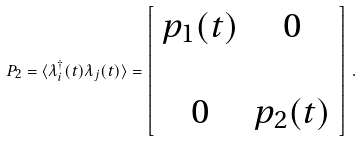Convert formula to latex. <formula><loc_0><loc_0><loc_500><loc_500>P _ { 2 } = \langle \lambda ^ { \dag } _ { i } ( t ) \lambda _ { j } ( t ) \rangle = \left [ \begin{array} { c c } p _ { 1 } ( t ) & 0 \\ & \\ 0 & p _ { 2 } ( t ) \end{array} \right ] \, .</formula> 